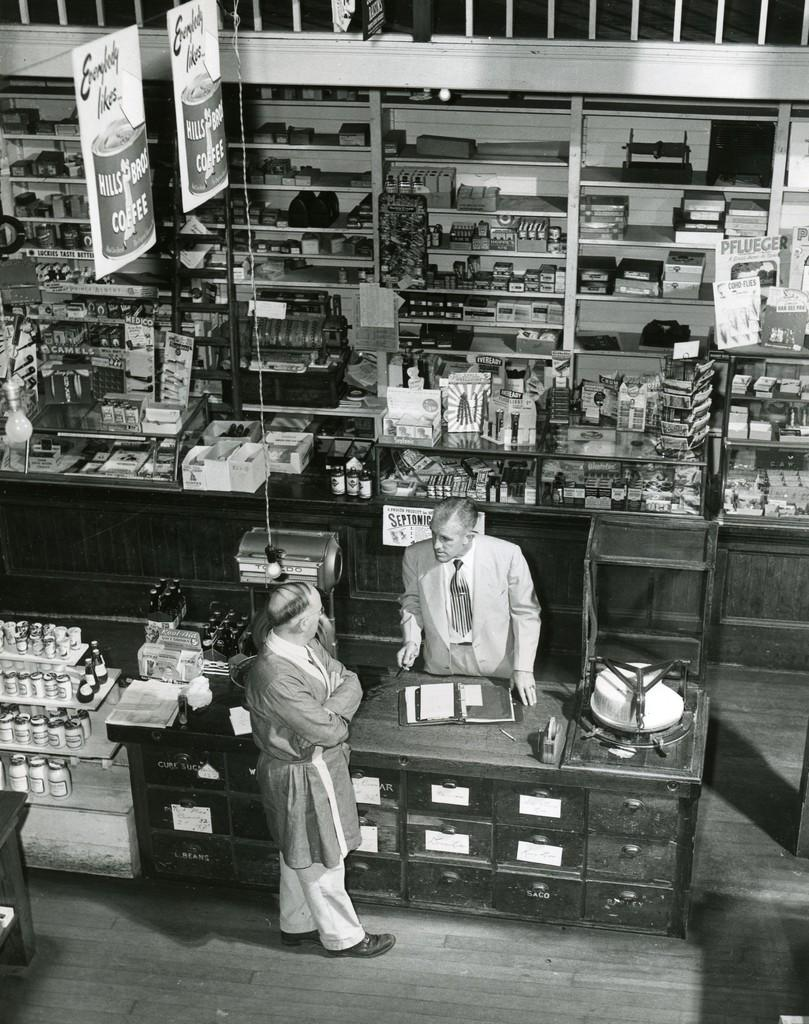<image>
Present a compact description of the photo's key features. A sign that is hanging up that says hills bros coffee on it. 